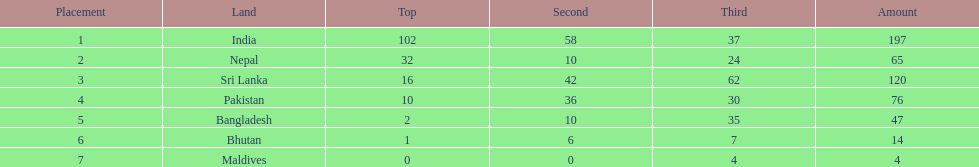Name the first country on the table? India. Could you parse the entire table? {'header': ['Placement', 'Land', 'Top', 'Second', 'Third', 'Amount'], 'rows': [['1', 'India', '102', '58', '37', '197'], ['2', 'Nepal', '32', '10', '24', '65'], ['3', 'Sri Lanka', '16', '42', '62', '120'], ['4', 'Pakistan', '10', '36', '30', '76'], ['5', 'Bangladesh', '2', '10', '35', '47'], ['6', 'Bhutan', '1', '6', '7', '14'], ['7', 'Maldives', '0', '0', '4', '4']]} 